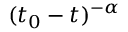Convert formula to latex. <formula><loc_0><loc_0><loc_500><loc_500>( t _ { 0 } - t ) ^ { - \alpha }</formula> 